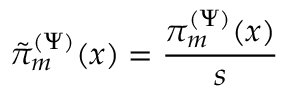<formula> <loc_0><loc_0><loc_500><loc_500>\tilde { \pi } _ { m } ^ { ( \Psi ) } ( x ) = \frac { \pi _ { m } ^ { ( \Psi ) } ( x ) } { s }</formula> 